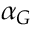<formula> <loc_0><loc_0><loc_500><loc_500>\alpha _ { G } \</formula> 